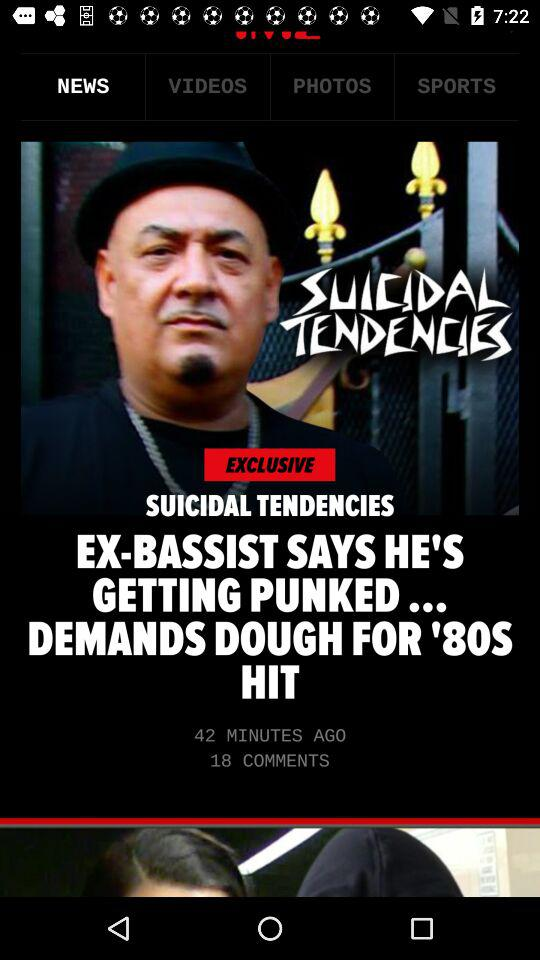How many comments for the news on the screen? There are 18 comments. 